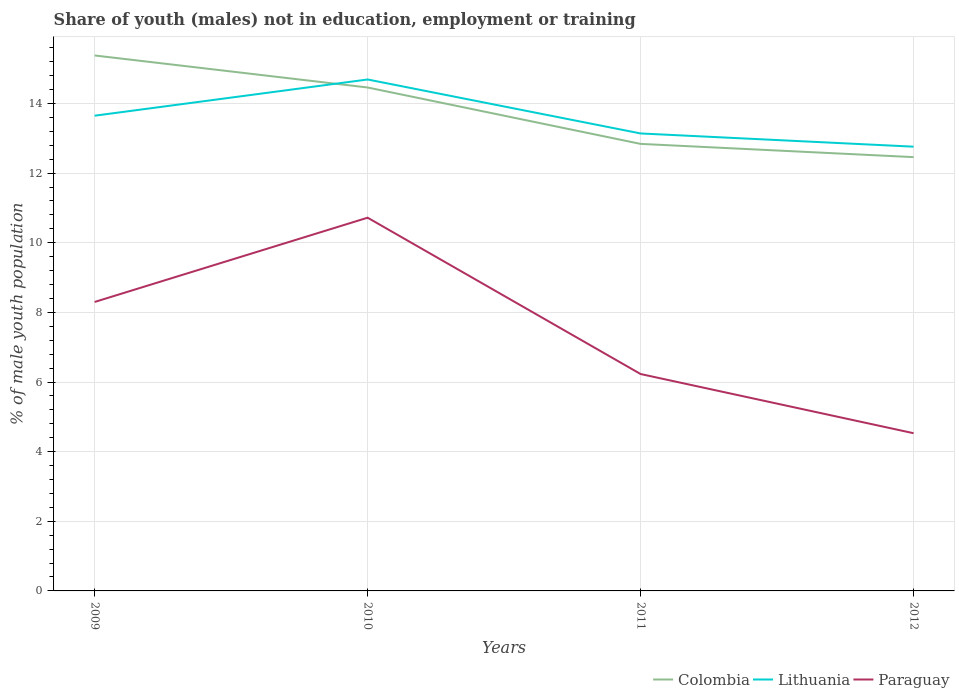Is the number of lines equal to the number of legend labels?
Offer a terse response. Yes. Across all years, what is the maximum percentage of unemployed males population in in Paraguay?
Your answer should be compact. 4.53. What is the total percentage of unemployed males population in in Lithuania in the graph?
Provide a short and direct response. 0.89. What is the difference between the highest and the second highest percentage of unemployed males population in in Paraguay?
Make the answer very short. 6.19. Is the percentage of unemployed males population in in Paraguay strictly greater than the percentage of unemployed males population in in Lithuania over the years?
Give a very brief answer. Yes. What is the difference between two consecutive major ticks on the Y-axis?
Your answer should be very brief. 2. Where does the legend appear in the graph?
Your answer should be compact. Bottom right. How many legend labels are there?
Make the answer very short. 3. What is the title of the graph?
Ensure brevity in your answer.  Share of youth (males) not in education, employment or training. Does "Malta" appear as one of the legend labels in the graph?
Keep it short and to the point. No. What is the label or title of the X-axis?
Your answer should be compact. Years. What is the label or title of the Y-axis?
Keep it short and to the point. % of male youth population. What is the % of male youth population of Colombia in 2009?
Make the answer very short. 15.38. What is the % of male youth population in Lithuania in 2009?
Make the answer very short. 13.65. What is the % of male youth population of Paraguay in 2009?
Provide a short and direct response. 8.3. What is the % of male youth population in Colombia in 2010?
Ensure brevity in your answer.  14.46. What is the % of male youth population of Lithuania in 2010?
Your answer should be very brief. 14.69. What is the % of male youth population of Paraguay in 2010?
Keep it short and to the point. 10.72. What is the % of male youth population in Colombia in 2011?
Offer a very short reply. 12.84. What is the % of male youth population of Lithuania in 2011?
Provide a succinct answer. 13.14. What is the % of male youth population in Paraguay in 2011?
Keep it short and to the point. 6.23. What is the % of male youth population in Colombia in 2012?
Your answer should be compact. 12.46. What is the % of male youth population in Lithuania in 2012?
Your answer should be compact. 12.76. What is the % of male youth population of Paraguay in 2012?
Give a very brief answer. 4.53. Across all years, what is the maximum % of male youth population in Colombia?
Your answer should be compact. 15.38. Across all years, what is the maximum % of male youth population in Lithuania?
Make the answer very short. 14.69. Across all years, what is the maximum % of male youth population of Paraguay?
Offer a very short reply. 10.72. Across all years, what is the minimum % of male youth population in Colombia?
Make the answer very short. 12.46. Across all years, what is the minimum % of male youth population in Lithuania?
Provide a succinct answer. 12.76. Across all years, what is the minimum % of male youth population of Paraguay?
Give a very brief answer. 4.53. What is the total % of male youth population in Colombia in the graph?
Provide a short and direct response. 55.14. What is the total % of male youth population in Lithuania in the graph?
Make the answer very short. 54.24. What is the total % of male youth population of Paraguay in the graph?
Keep it short and to the point. 29.78. What is the difference between the % of male youth population of Colombia in 2009 and that in 2010?
Keep it short and to the point. 0.92. What is the difference between the % of male youth population in Lithuania in 2009 and that in 2010?
Give a very brief answer. -1.04. What is the difference between the % of male youth population in Paraguay in 2009 and that in 2010?
Offer a very short reply. -2.42. What is the difference between the % of male youth population in Colombia in 2009 and that in 2011?
Your answer should be very brief. 2.54. What is the difference between the % of male youth population in Lithuania in 2009 and that in 2011?
Ensure brevity in your answer.  0.51. What is the difference between the % of male youth population of Paraguay in 2009 and that in 2011?
Your answer should be very brief. 2.07. What is the difference between the % of male youth population in Colombia in 2009 and that in 2012?
Offer a very short reply. 2.92. What is the difference between the % of male youth population of Lithuania in 2009 and that in 2012?
Make the answer very short. 0.89. What is the difference between the % of male youth population of Paraguay in 2009 and that in 2012?
Provide a short and direct response. 3.77. What is the difference between the % of male youth population in Colombia in 2010 and that in 2011?
Keep it short and to the point. 1.62. What is the difference between the % of male youth population of Lithuania in 2010 and that in 2011?
Your response must be concise. 1.55. What is the difference between the % of male youth population in Paraguay in 2010 and that in 2011?
Your answer should be very brief. 4.49. What is the difference between the % of male youth population in Colombia in 2010 and that in 2012?
Offer a terse response. 2. What is the difference between the % of male youth population in Lithuania in 2010 and that in 2012?
Your answer should be compact. 1.93. What is the difference between the % of male youth population of Paraguay in 2010 and that in 2012?
Your answer should be very brief. 6.19. What is the difference between the % of male youth population in Colombia in 2011 and that in 2012?
Provide a short and direct response. 0.38. What is the difference between the % of male youth population in Lithuania in 2011 and that in 2012?
Keep it short and to the point. 0.38. What is the difference between the % of male youth population of Colombia in 2009 and the % of male youth population of Lithuania in 2010?
Offer a very short reply. 0.69. What is the difference between the % of male youth population of Colombia in 2009 and the % of male youth population of Paraguay in 2010?
Your answer should be compact. 4.66. What is the difference between the % of male youth population of Lithuania in 2009 and the % of male youth population of Paraguay in 2010?
Offer a terse response. 2.93. What is the difference between the % of male youth population in Colombia in 2009 and the % of male youth population in Lithuania in 2011?
Give a very brief answer. 2.24. What is the difference between the % of male youth population in Colombia in 2009 and the % of male youth population in Paraguay in 2011?
Your answer should be very brief. 9.15. What is the difference between the % of male youth population of Lithuania in 2009 and the % of male youth population of Paraguay in 2011?
Your answer should be compact. 7.42. What is the difference between the % of male youth population of Colombia in 2009 and the % of male youth population of Lithuania in 2012?
Your response must be concise. 2.62. What is the difference between the % of male youth population of Colombia in 2009 and the % of male youth population of Paraguay in 2012?
Provide a succinct answer. 10.85. What is the difference between the % of male youth population of Lithuania in 2009 and the % of male youth population of Paraguay in 2012?
Offer a terse response. 9.12. What is the difference between the % of male youth population of Colombia in 2010 and the % of male youth population of Lithuania in 2011?
Give a very brief answer. 1.32. What is the difference between the % of male youth population of Colombia in 2010 and the % of male youth population of Paraguay in 2011?
Your response must be concise. 8.23. What is the difference between the % of male youth population of Lithuania in 2010 and the % of male youth population of Paraguay in 2011?
Provide a short and direct response. 8.46. What is the difference between the % of male youth population in Colombia in 2010 and the % of male youth population in Paraguay in 2012?
Provide a short and direct response. 9.93. What is the difference between the % of male youth population of Lithuania in 2010 and the % of male youth population of Paraguay in 2012?
Offer a terse response. 10.16. What is the difference between the % of male youth population in Colombia in 2011 and the % of male youth population in Lithuania in 2012?
Give a very brief answer. 0.08. What is the difference between the % of male youth population in Colombia in 2011 and the % of male youth population in Paraguay in 2012?
Offer a very short reply. 8.31. What is the difference between the % of male youth population in Lithuania in 2011 and the % of male youth population in Paraguay in 2012?
Offer a very short reply. 8.61. What is the average % of male youth population of Colombia per year?
Make the answer very short. 13.79. What is the average % of male youth population in Lithuania per year?
Provide a short and direct response. 13.56. What is the average % of male youth population in Paraguay per year?
Keep it short and to the point. 7.45. In the year 2009, what is the difference between the % of male youth population of Colombia and % of male youth population of Lithuania?
Provide a succinct answer. 1.73. In the year 2009, what is the difference between the % of male youth population of Colombia and % of male youth population of Paraguay?
Make the answer very short. 7.08. In the year 2009, what is the difference between the % of male youth population in Lithuania and % of male youth population in Paraguay?
Provide a succinct answer. 5.35. In the year 2010, what is the difference between the % of male youth population in Colombia and % of male youth population in Lithuania?
Offer a very short reply. -0.23. In the year 2010, what is the difference between the % of male youth population in Colombia and % of male youth population in Paraguay?
Ensure brevity in your answer.  3.74. In the year 2010, what is the difference between the % of male youth population of Lithuania and % of male youth population of Paraguay?
Your response must be concise. 3.97. In the year 2011, what is the difference between the % of male youth population in Colombia and % of male youth population in Paraguay?
Provide a succinct answer. 6.61. In the year 2011, what is the difference between the % of male youth population in Lithuania and % of male youth population in Paraguay?
Give a very brief answer. 6.91. In the year 2012, what is the difference between the % of male youth population in Colombia and % of male youth population in Lithuania?
Keep it short and to the point. -0.3. In the year 2012, what is the difference between the % of male youth population in Colombia and % of male youth population in Paraguay?
Your answer should be very brief. 7.93. In the year 2012, what is the difference between the % of male youth population of Lithuania and % of male youth population of Paraguay?
Offer a very short reply. 8.23. What is the ratio of the % of male youth population in Colombia in 2009 to that in 2010?
Make the answer very short. 1.06. What is the ratio of the % of male youth population in Lithuania in 2009 to that in 2010?
Offer a very short reply. 0.93. What is the ratio of the % of male youth population of Paraguay in 2009 to that in 2010?
Provide a succinct answer. 0.77. What is the ratio of the % of male youth population of Colombia in 2009 to that in 2011?
Provide a succinct answer. 1.2. What is the ratio of the % of male youth population in Lithuania in 2009 to that in 2011?
Offer a very short reply. 1.04. What is the ratio of the % of male youth population of Paraguay in 2009 to that in 2011?
Your response must be concise. 1.33. What is the ratio of the % of male youth population of Colombia in 2009 to that in 2012?
Provide a succinct answer. 1.23. What is the ratio of the % of male youth population in Lithuania in 2009 to that in 2012?
Ensure brevity in your answer.  1.07. What is the ratio of the % of male youth population of Paraguay in 2009 to that in 2012?
Provide a succinct answer. 1.83. What is the ratio of the % of male youth population of Colombia in 2010 to that in 2011?
Keep it short and to the point. 1.13. What is the ratio of the % of male youth population of Lithuania in 2010 to that in 2011?
Offer a very short reply. 1.12. What is the ratio of the % of male youth population in Paraguay in 2010 to that in 2011?
Your answer should be compact. 1.72. What is the ratio of the % of male youth population in Colombia in 2010 to that in 2012?
Ensure brevity in your answer.  1.16. What is the ratio of the % of male youth population in Lithuania in 2010 to that in 2012?
Provide a short and direct response. 1.15. What is the ratio of the % of male youth population in Paraguay in 2010 to that in 2012?
Provide a succinct answer. 2.37. What is the ratio of the % of male youth population of Colombia in 2011 to that in 2012?
Your answer should be compact. 1.03. What is the ratio of the % of male youth population in Lithuania in 2011 to that in 2012?
Offer a very short reply. 1.03. What is the ratio of the % of male youth population in Paraguay in 2011 to that in 2012?
Give a very brief answer. 1.38. What is the difference between the highest and the second highest % of male youth population in Colombia?
Provide a succinct answer. 0.92. What is the difference between the highest and the second highest % of male youth population in Lithuania?
Your answer should be compact. 1.04. What is the difference between the highest and the second highest % of male youth population of Paraguay?
Offer a terse response. 2.42. What is the difference between the highest and the lowest % of male youth population in Colombia?
Your answer should be compact. 2.92. What is the difference between the highest and the lowest % of male youth population in Lithuania?
Give a very brief answer. 1.93. What is the difference between the highest and the lowest % of male youth population in Paraguay?
Make the answer very short. 6.19. 